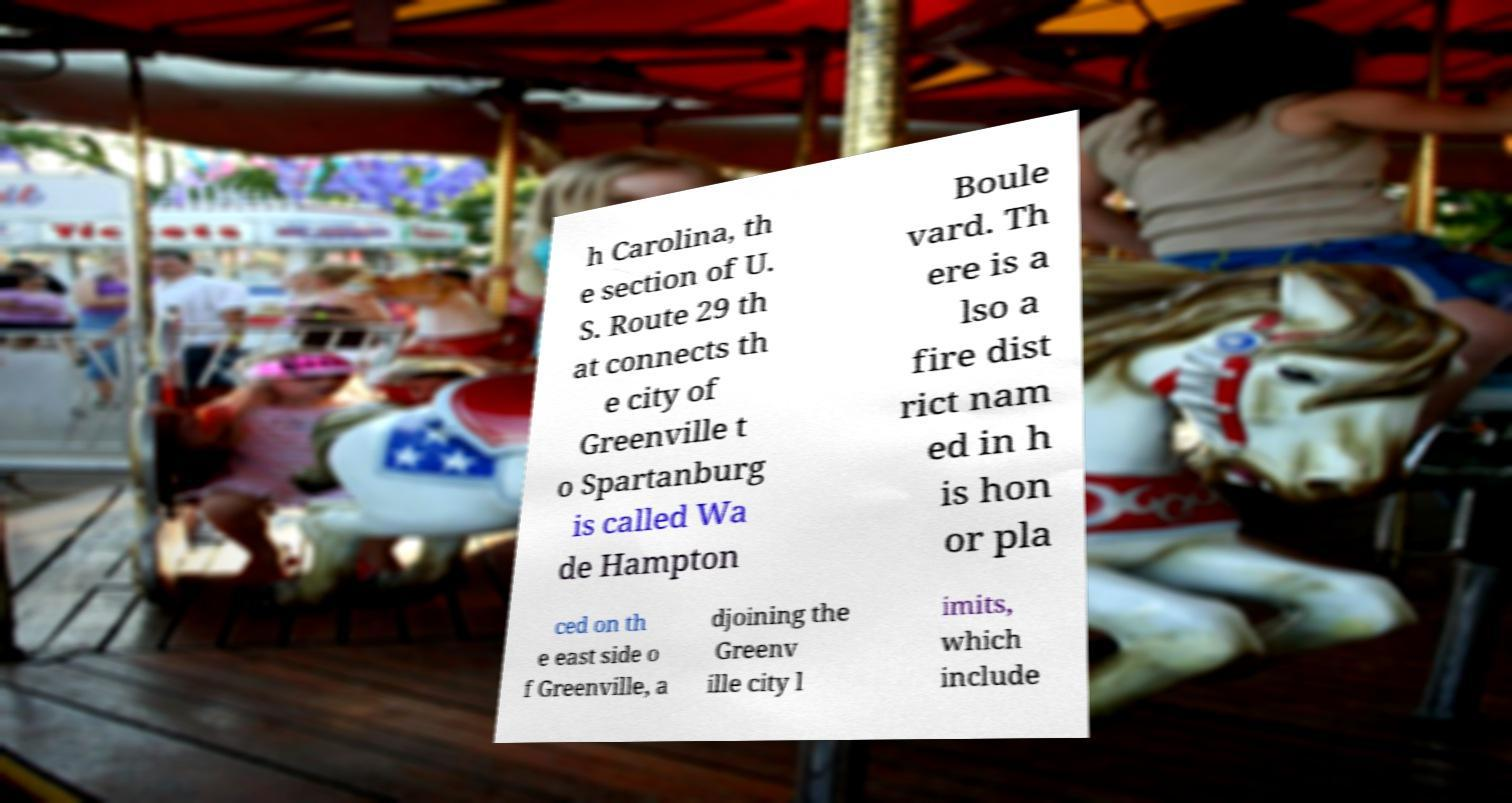There's text embedded in this image that I need extracted. Can you transcribe it verbatim? h Carolina, th e section of U. S. Route 29 th at connects th e city of Greenville t o Spartanburg is called Wa de Hampton Boule vard. Th ere is a lso a fire dist rict nam ed in h is hon or pla ced on th e east side o f Greenville, a djoining the Greenv ille city l imits, which include 